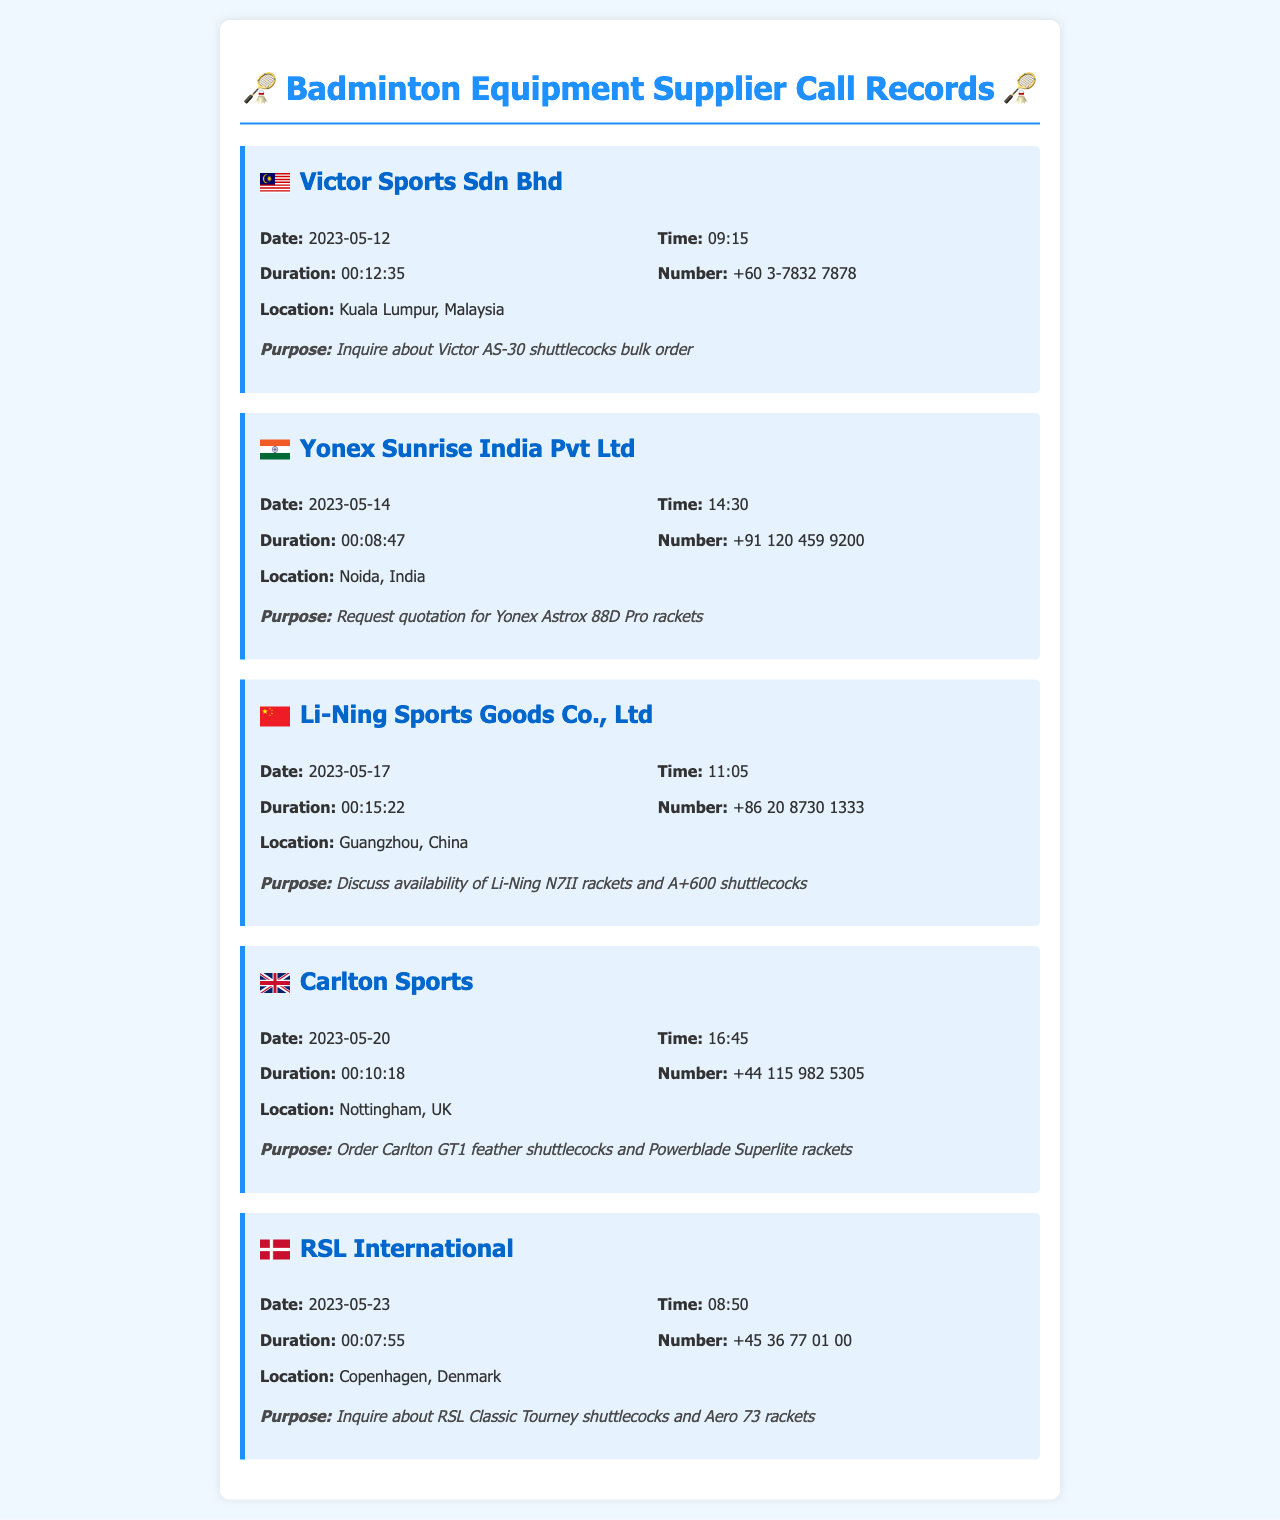what is the first supplier's name? The first supplier mentioned in the document is Victor Sports Sdn Bhd.
Answer: Victor Sports Sdn Bhd what is the date of the call to Yonex Sunrise India Pvt Ltd? The date of the call is provided in the call record for Yonex Sunrise India Pvt Ltd, which is May 14, 2023.
Answer: 2023-05-14 how long was the call to RSL International? The duration of the call to RSL International is noted in the call record, which is 7 minutes and 55 seconds.
Answer: 00:07:55 what was discussed during the call to Li-Ning Sports Goods Co., Ltd? The purpose of the call to Li-Ning Sports Goods Co., Ltd was to discuss availability of certain equipment, as noted in the record.
Answer: Availability of Li-Ning N7II rackets and A+600 shuttlecocks which country is Carlton Sports located in? The document specifies the location of Carlton Sports as being in Nottingham, UK, which indicates the country.
Answer: UK how many suppliers were contacted in total? By counting each item in the document, we can determine the total number of suppliers contacted.
Answer: 5 what time was the call to Victor Sports Sdn Bhd made? The document specifies the time for the call to Victor Sports Sdn Bhd as 09:15.
Answer: 09:15 what type of products were ordered from Carlton Sports? The purpose of the call to Carlton Sports includes the specific products ordered, which are listed in the document.
Answer: Carlton GT1 feather shuttlecocks and Powerblade Superlite rackets 